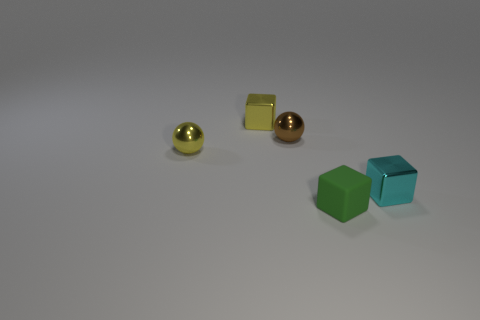Are there any other things that are made of the same material as the green cube?
Keep it short and to the point. No. Are there fewer things that are on the left side of the tiny cyan object than yellow cubes that are on the right side of the tiny green object?
Your answer should be very brief. No. Is there any other thing that has the same color as the small rubber thing?
Provide a short and direct response. No. The cyan thing has what shape?
Keep it short and to the point. Cube. What color is the other ball that is the same material as the brown sphere?
Provide a short and direct response. Yellow. Are there more rubber cubes than big yellow metal cubes?
Keep it short and to the point. Yes. Are any cubes visible?
Give a very brief answer. Yes. What is the shape of the yellow thing on the left side of the small yellow thing that is behind the yellow metallic ball?
Provide a succinct answer. Sphere. What number of things are either shiny spheres or yellow metal objects on the right side of the yellow metallic ball?
Make the answer very short. 3. The block that is behind the ball that is to the left of the tiny yellow metal thing behind the small brown thing is what color?
Your answer should be compact. Yellow. 